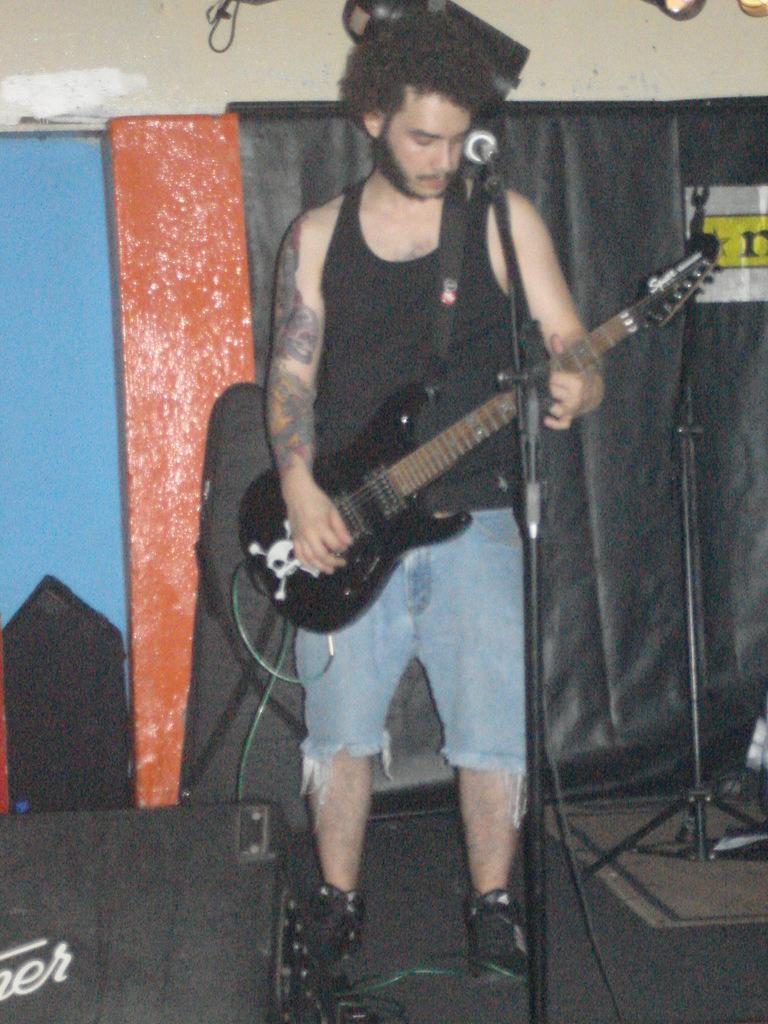How would you summarize this image in a sentence or two? In the picture, a man is wearing a black vest, he is holding a guitar behind him there is a black color carpet, in the background there is a cream wall. 